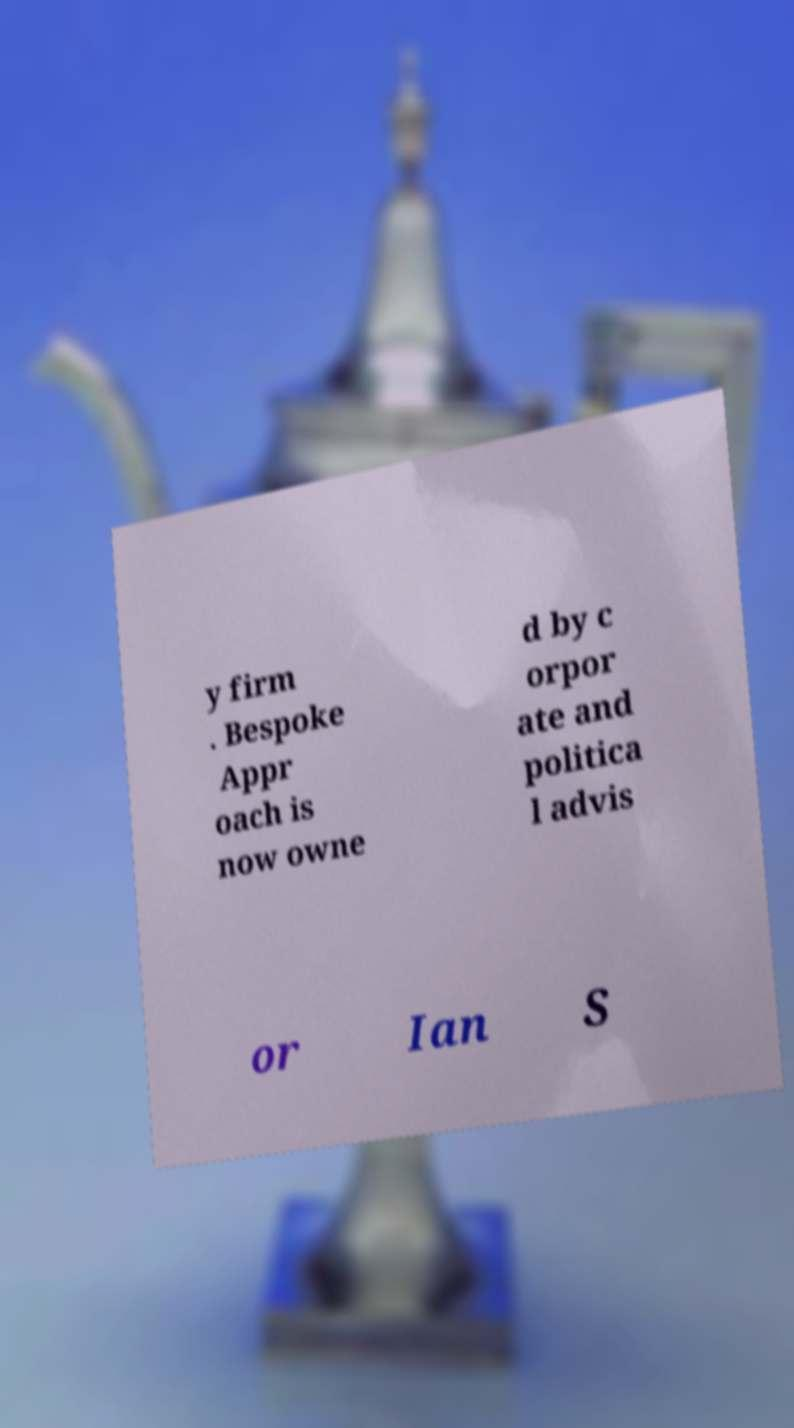For documentation purposes, I need the text within this image transcribed. Could you provide that? y firm . Bespoke Appr oach is now owne d by c orpor ate and politica l advis or Ian S 